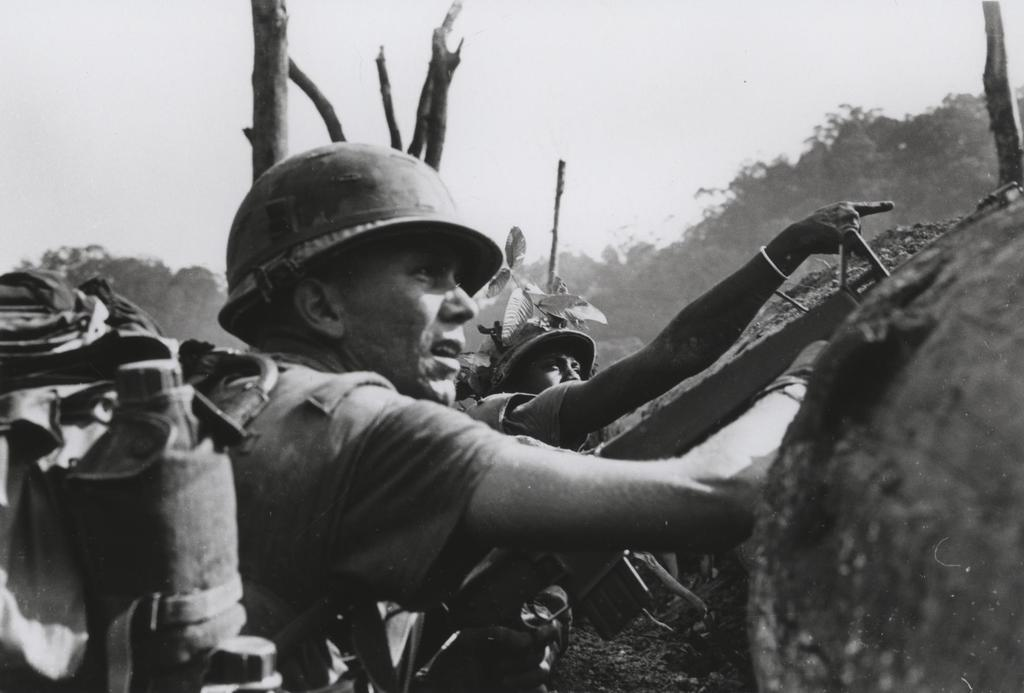What are the people in the image wearing on their heads? The people in the image are wearing helmets. What are the people carrying in the image? The people are carrying bags. What can be seen in the background of the image? There are many trees and the sky visible in the background of the image. What is the color scheme of the image? The image is black and white. What type of health advice can be seen on the ship in the image? There is no ship present in the image, and therefore no health advice can be seen. How does the self-awareness of the people in the image affect their actions? The image does not provide information about the self-awareness of the people, so it cannot be determined how it affects their actions. 